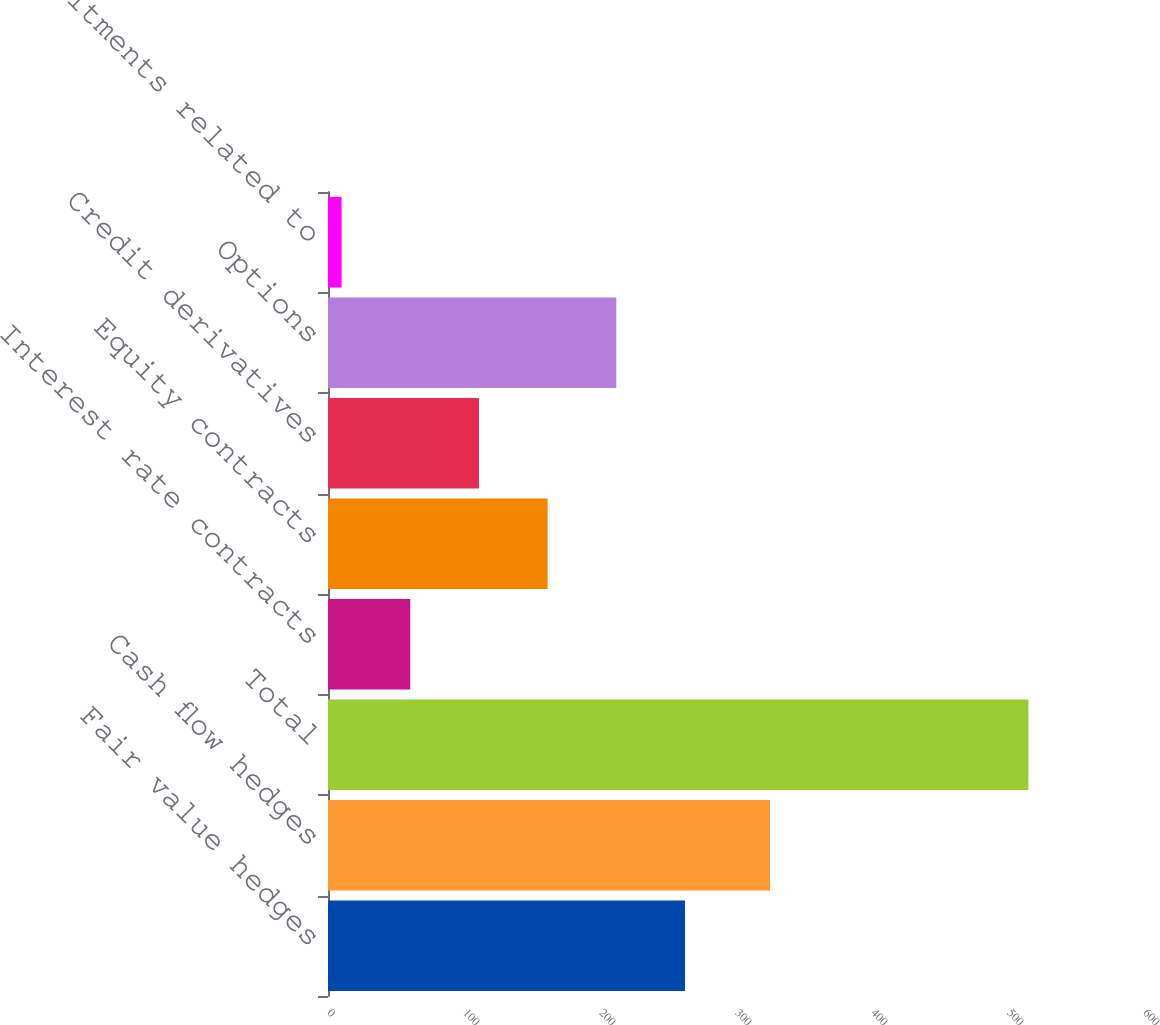<chart> <loc_0><loc_0><loc_500><loc_500><bar_chart><fcel>Fair value hedges<fcel>Cash flow hedges<fcel>Total<fcel>Interest rate contracts<fcel>Equity contracts<fcel>Credit derivatives<fcel>Options<fcel>Commitments related to<nl><fcel>262.5<fcel>325<fcel>515<fcel>60.5<fcel>161.5<fcel>111<fcel>212<fcel>10<nl></chart> 